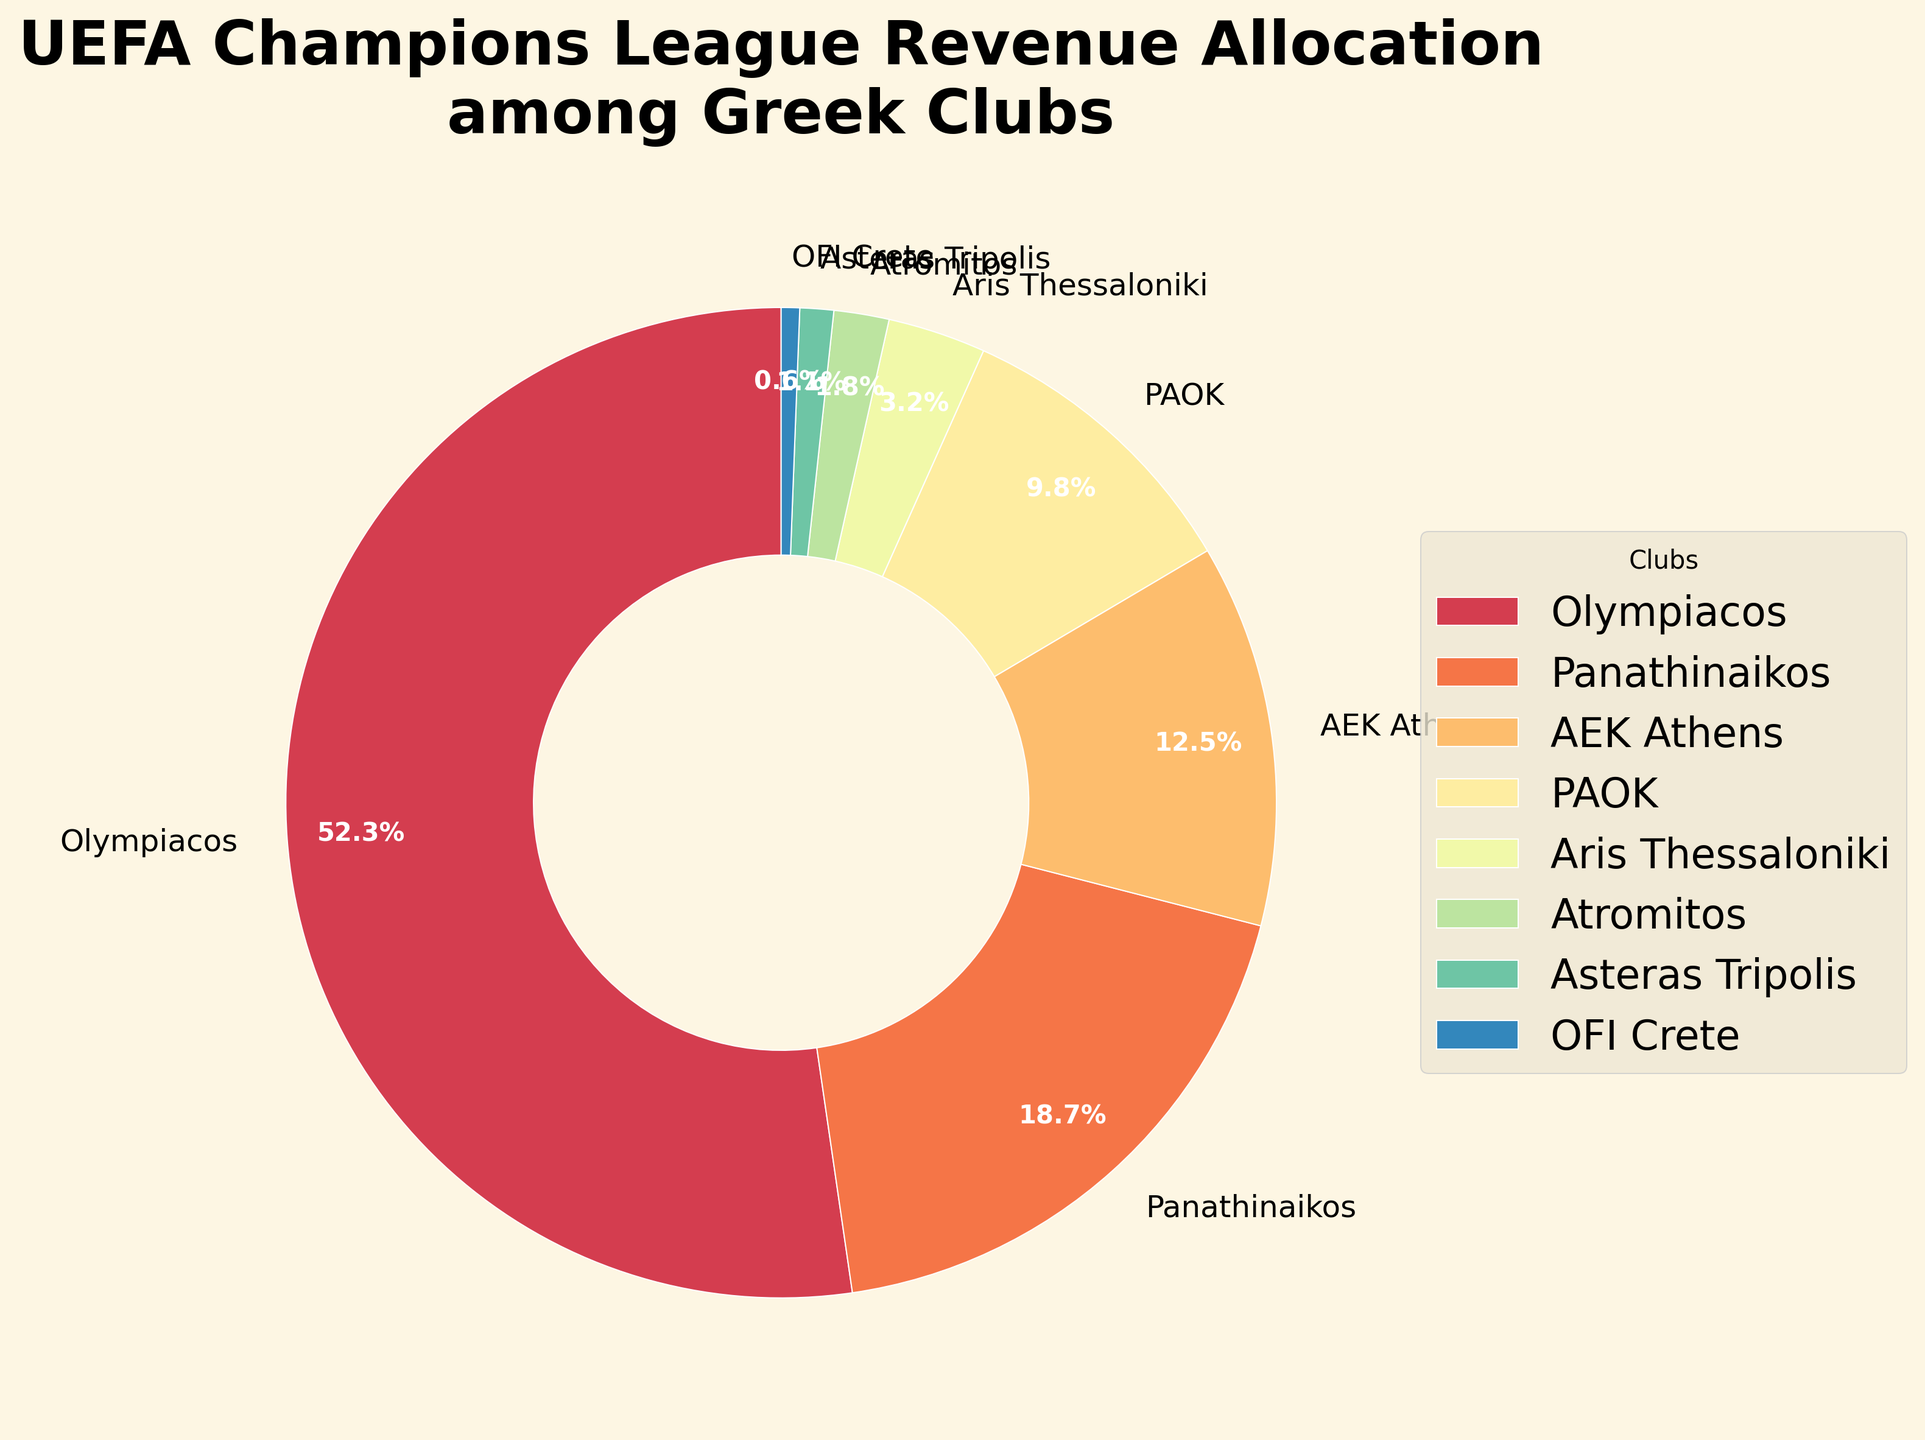Which club has the highest revenue share? By looking at the pie chart, the wedge for Olympiacos is the largest, meaning they have the highest revenue share.
Answer: Olympiacos Which club has the smallest revenue share? The smallest wedge in the pie chart belongs to OFI Crete, indicating they have the smallest revenue share.
Answer: OFI Crete How much more revenue share does Olympiacos have compared to Panathinaikos? Olympiacos has a revenue share of 52.3%, and Panathinaikos has 18.7%. The difference is 52.3% - 18.7%.
Answer: 33.6% What is the total revenue share of the bottom three clubs? The revenue shares of Aris Thessaloniki (3.2%), Atromitos (1.8%), and Asteras Tripolis (1.1%) sum up to 3.2% + 1.8% + 1.1%.
Answer: 6.1% Is the revenue share of Olympiacos more than half of the total revenue share? The pie chart shows Olympiacos with 52.3%. Since 52.3% is more than 50%, the revenue share of Olympiacos is indeed more than half.
Answer: Yes Which clubs have a revenue share greater than 10%? By examining the pie chart, the clubs with wedges indicating shares greater than 10% are Olympiacos (52.3%) and Panathinaikos (18.7%), and AEK Athens (12.5%).
Answer: Olympiacos, Panathinaikos, AEK Athens What is the combined revenue share of PAOK and Aris Thessaloniki? PAOK has a revenue share of 9.8%, and Aris Thessaloniki has 3.2%. Adding these together gives 9.8% + 3.2%.
Answer: 13% How does the revenue share of Panathinaikos compare to that of AEK Athens? Panathinaikos has a revenue share of 18.7%, while AEK Athens has 12.5%. By comparing these values, Panathinaikos has a higher share.
Answer: Panathinaikos has a higher share Is there any club with a revenue share exactly equal to 10%? By looking at the pie chart, there is no wedge that corresponds to a revenue share of exactly 10%.
Answer: No 